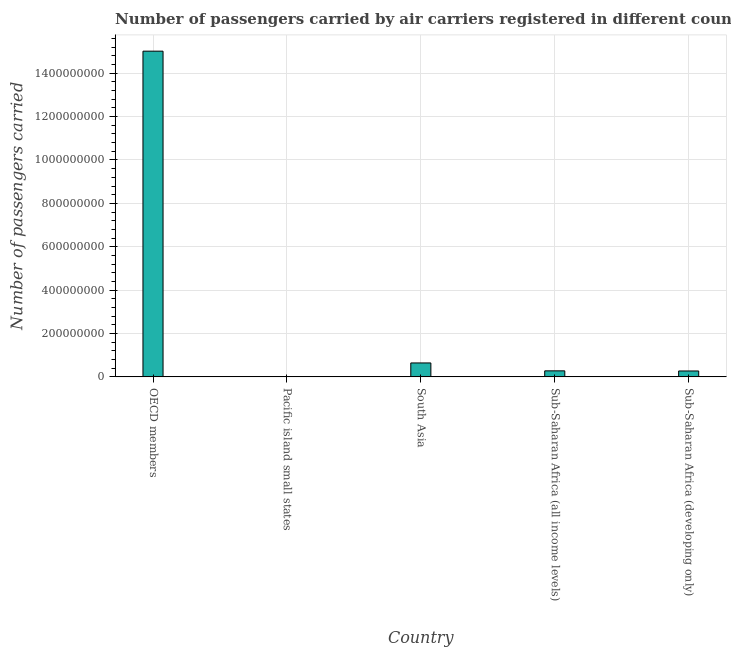Does the graph contain any zero values?
Your response must be concise. No. Does the graph contain grids?
Make the answer very short. Yes. What is the title of the graph?
Give a very brief answer. Number of passengers carried by air carriers registered in different countries. What is the label or title of the X-axis?
Your response must be concise. Country. What is the label or title of the Y-axis?
Keep it short and to the point. Number of passengers carried. What is the number of passengers carried in Pacific island small states?
Give a very brief answer. 1.65e+06. Across all countries, what is the maximum number of passengers carried?
Make the answer very short. 1.50e+09. Across all countries, what is the minimum number of passengers carried?
Ensure brevity in your answer.  1.65e+06. In which country was the number of passengers carried minimum?
Provide a short and direct response. Pacific island small states. What is the sum of the number of passengers carried?
Offer a terse response. 1.62e+09. What is the difference between the number of passengers carried in Pacific island small states and South Asia?
Offer a terse response. -6.25e+07. What is the average number of passengers carried per country?
Your answer should be compact. 3.25e+08. What is the median number of passengers carried?
Your response must be concise. 2.77e+07. In how many countries, is the number of passengers carried greater than 1320000000 ?
Provide a succinct answer. 1. What is the ratio of the number of passengers carried in Pacific island small states to that in South Asia?
Your answer should be compact. 0.03. What is the difference between the highest and the second highest number of passengers carried?
Offer a very short reply. 1.44e+09. Is the sum of the number of passengers carried in Pacific island small states and Sub-Saharan Africa (all income levels) greater than the maximum number of passengers carried across all countries?
Provide a short and direct response. No. What is the difference between the highest and the lowest number of passengers carried?
Offer a very short reply. 1.50e+09. Are all the bars in the graph horizontal?
Make the answer very short. No. What is the difference between two consecutive major ticks on the Y-axis?
Ensure brevity in your answer.  2.00e+08. What is the Number of passengers carried of OECD members?
Your answer should be compact. 1.50e+09. What is the Number of passengers carried in Pacific island small states?
Offer a very short reply. 1.65e+06. What is the Number of passengers carried in South Asia?
Ensure brevity in your answer.  6.42e+07. What is the Number of passengers carried of Sub-Saharan Africa (all income levels)?
Offer a very short reply. 2.77e+07. What is the Number of passengers carried of Sub-Saharan Africa (developing only)?
Keep it short and to the point. 2.72e+07. What is the difference between the Number of passengers carried in OECD members and Pacific island small states?
Provide a short and direct response. 1.50e+09. What is the difference between the Number of passengers carried in OECD members and South Asia?
Offer a very short reply. 1.44e+09. What is the difference between the Number of passengers carried in OECD members and Sub-Saharan Africa (all income levels)?
Provide a short and direct response. 1.47e+09. What is the difference between the Number of passengers carried in OECD members and Sub-Saharan Africa (developing only)?
Offer a terse response. 1.47e+09. What is the difference between the Number of passengers carried in Pacific island small states and South Asia?
Your response must be concise. -6.25e+07. What is the difference between the Number of passengers carried in Pacific island small states and Sub-Saharan Africa (all income levels)?
Offer a terse response. -2.61e+07. What is the difference between the Number of passengers carried in Pacific island small states and Sub-Saharan Africa (developing only)?
Provide a short and direct response. -2.55e+07. What is the difference between the Number of passengers carried in South Asia and Sub-Saharan Africa (all income levels)?
Your answer should be very brief. 3.64e+07. What is the difference between the Number of passengers carried in South Asia and Sub-Saharan Africa (developing only)?
Keep it short and to the point. 3.70e+07. What is the difference between the Number of passengers carried in Sub-Saharan Africa (all income levels) and Sub-Saharan Africa (developing only)?
Ensure brevity in your answer.  5.65e+05. What is the ratio of the Number of passengers carried in OECD members to that in Pacific island small states?
Offer a very short reply. 909.42. What is the ratio of the Number of passengers carried in OECD members to that in South Asia?
Provide a short and direct response. 23.39. What is the ratio of the Number of passengers carried in OECD members to that in Sub-Saharan Africa (all income levels)?
Your response must be concise. 54.12. What is the ratio of the Number of passengers carried in OECD members to that in Sub-Saharan Africa (developing only)?
Your answer should be compact. 55.24. What is the ratio of the Number of passengers carried in Pacific island small states to that in South Asia?
Your answer should be very brief. 0.03. What is the ratio of the Number of passengers carried in Pacific island small states to that in Sub-Saharan Africa (all income levels)?
Offer a very short reply. 0.06. What is the ratio of the Number of passengers carried in Pacific island small states to that in Sub-Saharan Africa (developing only)?
Provide a succinct answer. 0.06. What is the ratio of the Number of passengers carried in South Asia to that in Sub-Saharan Africa (all income levels)?
Make the answer very short. 2.31. What is the ratio of the Number of passengers carried in South Asia to that in Sub-Saharan Africa (developing only)?
Keep it short and to the point. 2.36. What is the ratio of the Number of passengers carried in Sub-Saharan Africa (all income levels) to that in Sub-Saharan Africa (developing only)?
Your response must be concise. 1.02. 